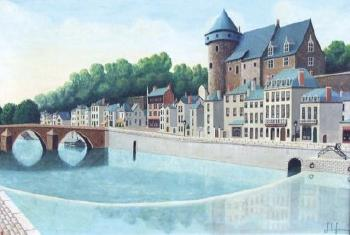Explain the visual content of the image in great detail. The image depicts a beautiful, tranquil European town situated beside a calm river that shines under a clear sky. On the right, there is a castle-like building with a prominent turret, suggesting historical significance and possibly a tourist attraction. Across the river are multiple arched bridges, which not only serve as practical connections between different parts of the town but also add aesthetic value to the landscape. The buildings, painted in soothing shades of white, beige, and pale red, feature traditional European architectural elements such as gabled roofs and quaint windows. This setting is likely a popular spot for both local residents and visitors for leisurely walks and appreciating the town's picturesque charm. 